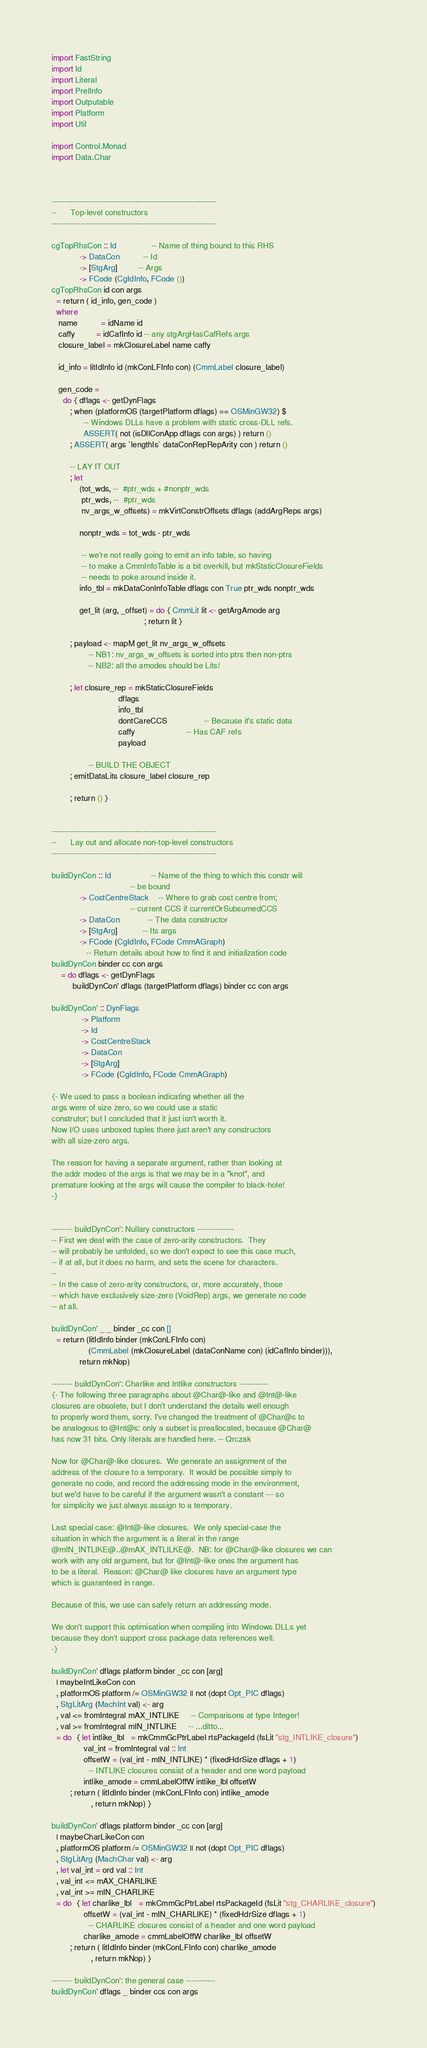<code> <loc_0><loc_0><loc_500><loc_500><_Haskell_>import FastString
import Id
import Literal
import PrelInfo
import Outputable
import Platform
import Util

import Control.Monad
import Data.Char



---------------------------------------------------------------
--      Top-level constructors
---------------------------------------------------------------

cgTopRhsCon :: Id               -- Name of thing bound to this RHS
            -> DataCon          -- Id
            -> [StgArg]         -- Args
            -> FCode (CgIdInfo, FCode ())
cgTopRhsCon id con args
  = return ( id_info, gen_code )
  where
   name          = idName id
   caffy         = idCafInfo id -- any stgArgHasCafRefs args
   closure_label = mkClosureLabel name caffy

   id_info = litIdInfo id (mkConLFInfo con) (CmmLabel closure_label)

   gen_code =
     do { dflags <- getDynFlags
        ; when (platformOS (targetPlatform dflags) == OSMinGW32) $
              -- Windows DLLs have a problem with static cross-DLL refs.
              ASSERT( not (isDllConApp dflags con args) ) return ()
        ; ASSERT( args `lengthIs` dataConRepRepArity con ) return ()

        -- LAY IT OUT
        ; let
            (tot_wds, --  #ptr_wds + #nonptr_wds
             ptr_wds, --  #ptr_wds
             nv_args_w_offsets) = mkVirtConstrOffsets dflags (addArgReps args)

            nonptr_wds = tot_wds - ptr_wds

             -- we're not really going to emit an info table, so having
             -- to make a CmmInfoTable is a bit overkill, but mkStaticClosureFields
             -- needs to poke around inside it.
            info_tbl = mkDataConInfoTable dflags con True ptr_wds nonptr_wds

            get_lit (arg, _offset) = do { CmmLit lit <- getArgAmode arg
                                        ; return lit }

        ; payload <- mapM get_lit nv_args_w_offsets
                -- NB1: nv_args_w_offsets is sorted into ptrs then non-ptrs
                -- NB2: all the amodes should be Lits!

        ; let closure_rep = mkStaticClosureFields
                             dflags
                             info_tbl
                             dontCareCCS                -- Because it's static data
                             caffy                      -- Has CAF refs
                             payload

                -- BUILD THE OBJECT
        ; emitDataLits closure_label closure_rep

        ; return () }


---------------------------------------------------------------
--      Lay out and allocate non-top-level constructors
---------------------------------------------------------------

buildDynCon :: Id                 -- Name of the thing to which this constr will
                                  -- be bound
            -> CostCentreStack    -- Where to grab cost centre from;
                                  -- current CCS if currentOrSubsumedCCS
            -> DataCon            -- The data constructor
            -> [StgArg]           -- Its args
            -> FCode (CgIdInfo, FCode CmmAGraph)
               -- Return details about how to find it and initialization code
buildDynCon binder cc con args
    = do dflags <- getDynFlags
         buildDynCon' dflags (targetPlatform dflags) binder cc con args

buildDynCon' :: DynFlags
             -> Platform
             -> Id
             -> CostCentreStack
             -> DataCon
             -> [StgArg]
             -> FCode (CgIdInfo, FCode CmmAGraph)

{- We used to pass a boolean indicating whether all the
args were of size zero, so we could use a static
construtor; but I concluded that it just isn't worth it.
Now I/O uses unboxed tuples there just aren't any constructors
with all size-zero args.

The reason for having a separate argument, rather than looking at
the addr modes of the args is that we may be in a "knot", and
premature looking at the args will cause the compiler to black-hole!
-}


-------- buildDynCon': Nullary constructors --------------
-- First we deal with the case of zero-arity constructors.  They
-- will probably be unfolded, so we don't expect to see this case much,
-- if at all, but it does no harm, and sets the scene for characters.
--
-- In the case of zero-arity constructors, or, more accurately, those
-- which have exclusively size-zero (VoidRep) args, we generate no code
-- at all.

buildDynCon' _ _ binder _cc con []
  = return (litIdInfo binder (mkConLFInfo con)
                (CmmLabel (mkClosureLabel (dataConName con) (idCafInfo binder))),
            return mkNop)

-------- buildDynCon': Charlike and Intlike constructors -----------
{- The following three paragraphs about @Char@-like and @Int@-like
closures are obsolete, but I don't understand the details well enough
to properly word them, sorry. I've changed the treatment of @Char@s to
be analogous to @Int@s: only a subset is preallocated, because @Char@
has now 31 bits. Only literals are handled here. -- Qrczak

Now for @Char@-like closures.  We generate an assignment of the
address of the closure to a temporary.  It would be possible simply to
generate no code, and record the addressing mode in the environment,
but we'd have to be careful if the argument wasn't a constant --- so
for simplicity we just always asssign to a temporary.

Last special case: @Int@-like closures.  We only special-case the
situation in which the argument is a literal in the range
@mIN_INTLIKE@..@mAX_INTLILKE@.  NB: for @Char@-like closures we can
work with any old argument, but for @Int@-like ones the argument has
to be a literal.  Reason: @Char@ like closures have an argument type
which is guaranteed in range.

Because of this, we use can safely return an addressing mode.

We don't support this optimisation when compiling into Windows DLLs yet
because they don't support cross package data references well.
-}

buildDynCon' dflags platform binder _cc con [arg]
  | maybeIntLikeCon con
  , platformOS platform /= OSMinGW32 || not (dopt Opt_PIC dflags)
  , StgLitArg (MachInt val) <- arg
  , val <= fromIntegral mAX_INTLIKE     -- Comparisons at type Integer!
  , val >= fromIntegral mIN_INTLIKE     -- ...ditto...
  = do  { let intlike_lbl   = mkCmmGcPtrLabel rtsPackageId (fsLit "stg_INTLIKE_closure")
              val_int = fromIntegral val :: Int
              offsetW = (val_int - mIN_INTLIKE) * (fixedHdrSize dflags + 1)
                -- INTLIKE closures consist of a header and one word payload
              intlike_amode = cmmLabelOffW intlike_lbl offsetW
        ; return ( litIdInfo binder (mkConLFInfo con) intlike_amode
                 , return mkNop) }

buildDynCon' dflags platform binder _cc con [arg]
  | maybeCharLikeCon con
  , platformOS platform /= OSMinGW32 || not (dopt Opt_PIC dflags)
  , StgLitArg (MachChar val) <- arg
  , let val_int = ord val :: Int
  , val_int <= mAX_CHARLIKE
  , val_int >= mIN_CHARLIKE
  = do  { let charlike_lbl   = mkCmmGcPtrLabel rtsPackageId (fsLit "stg_CHARLIKE_closure")
              offsetW = (val_int - mIN_CHARLIKE) * (fixedHdrSize dflags + 1)
                -- CHARLIKE closures consist of a header and one word payload
              charlike_amode = cmmLabelOffW charlike_lbl offsetW
        ; return ( litIdInfo binder (mkConLFInfo con) charlike_amode
                 , return mkNop) }

-------- buildDynCon': the general case -----------
buildDynCon' dflags _ binder ccs con args</code> 